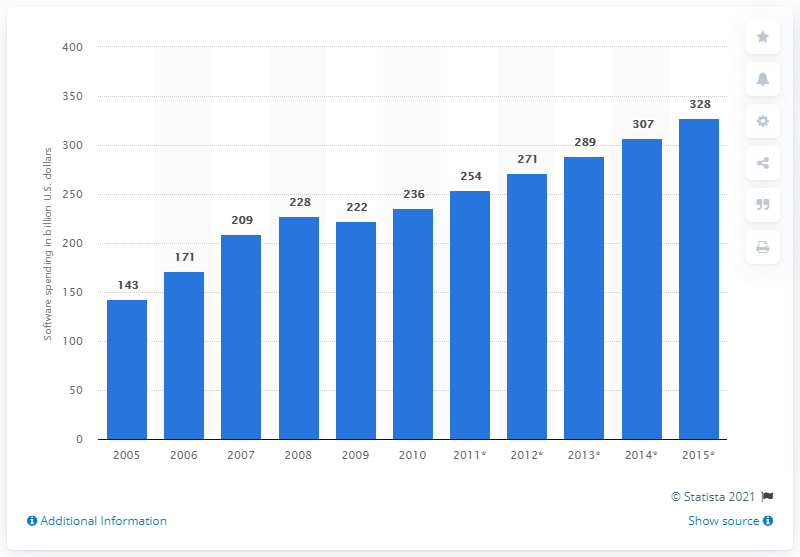Specify some key components in this picture. According to projections, global software spending is expected to total approximately 271 billion US dollars in 2012. 